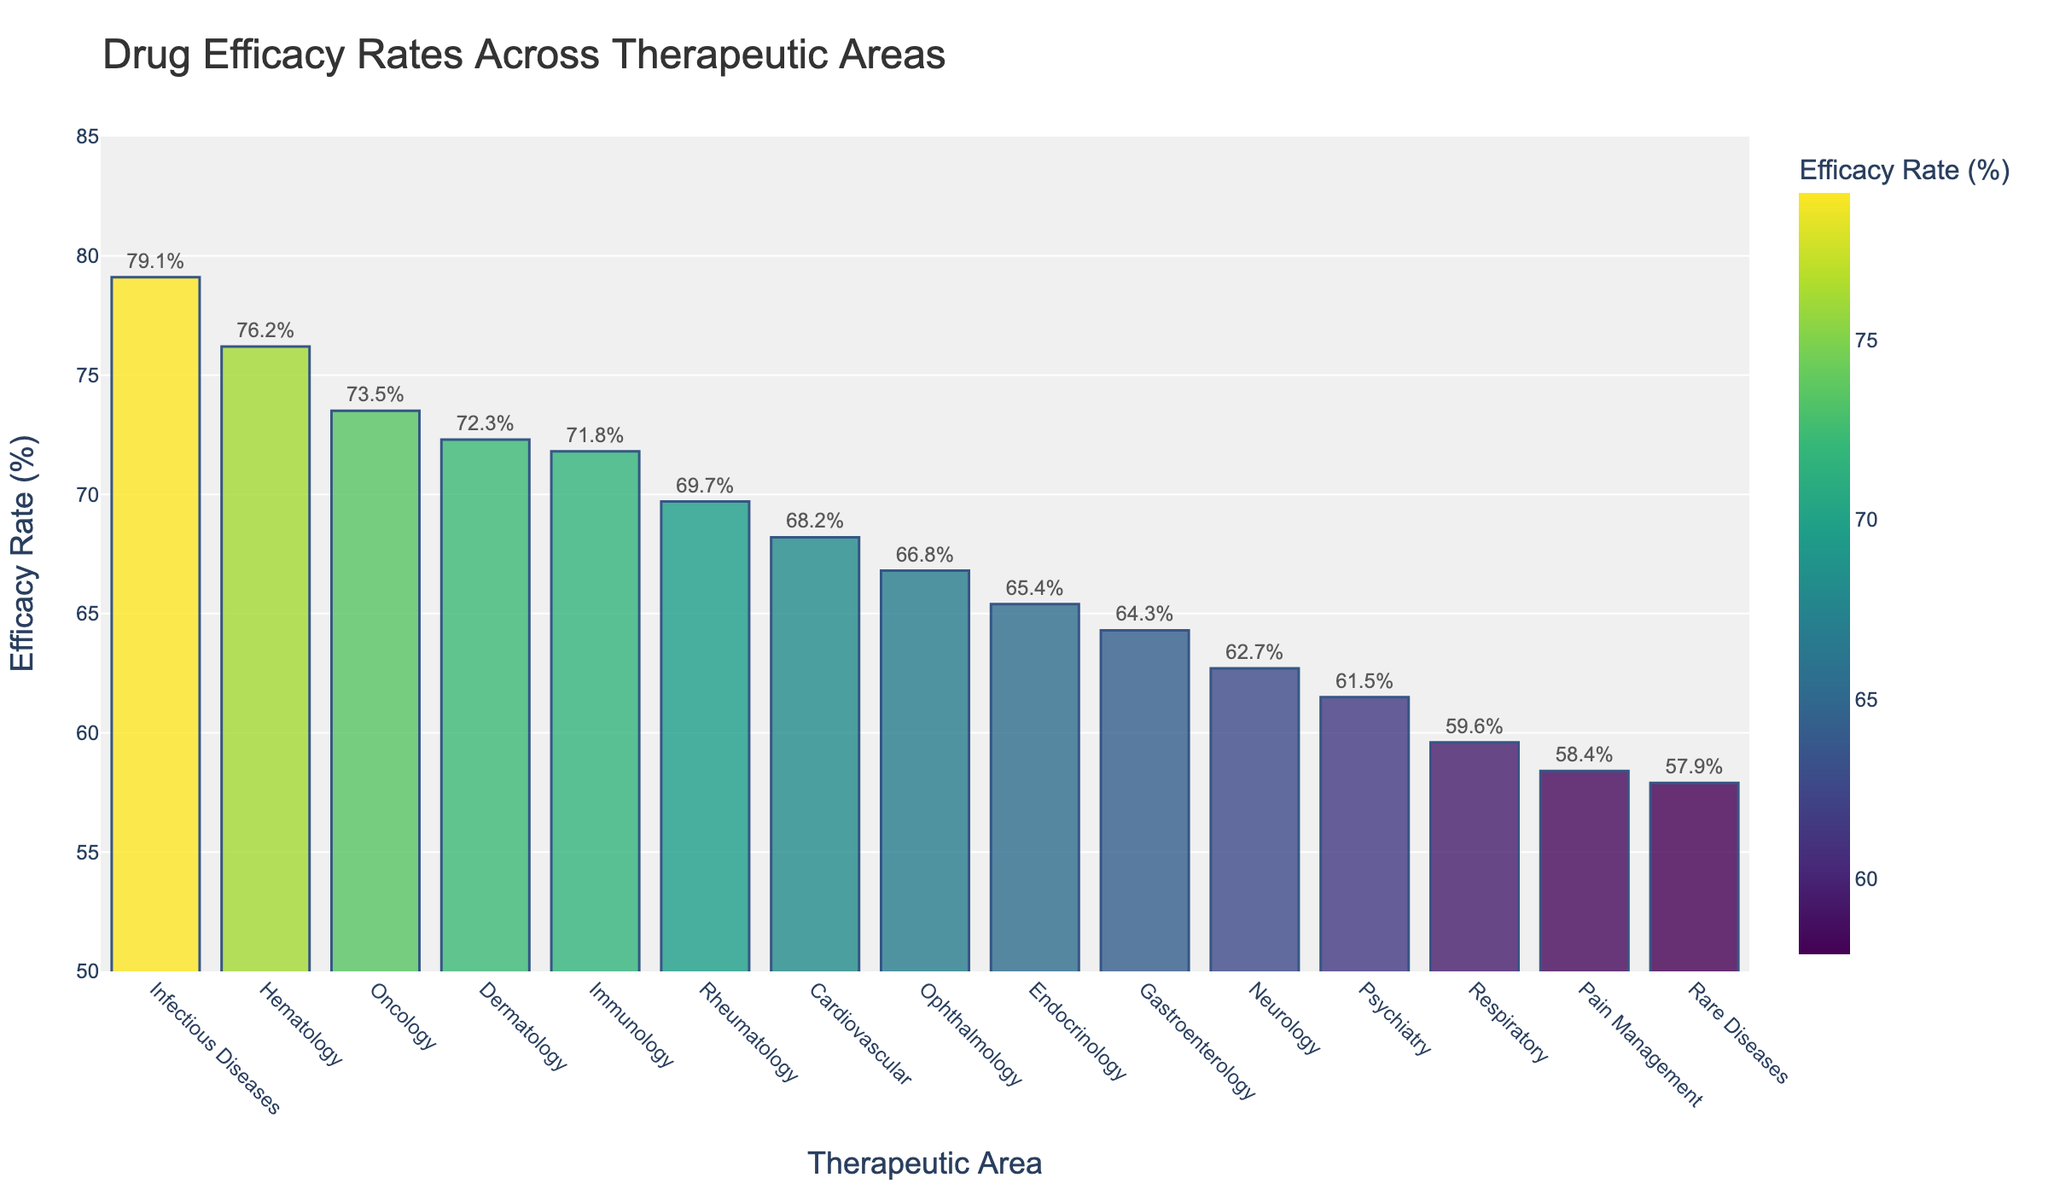Which therapeutic area has the highest drug efficacy rate? By visually inspecting the bar chart, we can identify the tallest bar. The therapeutic area with the highest bar represents the one with the highest drug efficacy rate.
Answer: Infectious Diseases Which therapeutic area has the lowest drug efficacy rate? Observing the bar chart, we look for the shortest bar as it represents the lowest drug efficacy rate among all therapeutic areas.
Answer: Rare Diseases How much higher is the efficacy rate of Oncology compared to Psychiatry? Locate the bars for Oncology and Psychiatry by the therapeutic areas on the x-axis. The height difference between these bars corresponds to their efficacy rate difference. Oncology is 73.5%, and Psychiatry is 61.5%. The calculation is 73.5% - 61.5% = 12%.
Answer: 12% What is the average efficacy rate of Oncology, Hematology, and Dermatology? Find the efficacy rates for the three therapeutic areas: Oncology (73.5%), Hematology (76.2%), and Dermatology (72.3%). Add these rates: 73.5 + 76.2 + 72.3 = 222. Divide the sum by 3 to find the average: 222 / 3 = 74%.
Answer: 74% Are there more therapeutic areas with efficacy rates above or below 65%? By counting the number of bars above and below the 65% mark, we determine how many therapeutic areas fall into each category. There are 8 therapeutic areas above 65% and 7 below.
Answer: Above Which two therapeutic areas have an efficacy rate closest to each other? Identifying bars with heights very close to each other, we find the efficacy rates for these therapeutic areas. Ophthalmology (66.8%) and Endocrinology (65.4%) have a small difference of 66.8% - 65.4% = 1.4%.
Answer: Ophthalmology and Endocrinology How much greater is the efficacy rate of Cardiovascular compared to Pain Management? Locate the bars for Cardiovascular and Pain Management. Cardiovascular is 68.2%, and Pain Management is 58.4%. The difference is calculated as 68.2% - 58.4% = 9.8%.
Answer: 9.8% Which therapeutic area has a higher efficacy rate: Neurology or Rheumatology? By comparing the heights of the bars for Neurology (62.7%) and Rheumatology (69.7%), we can determine which is higher. Rheumatology is higher than Neurology.
Answer: Rheumatology What is the range of drug efficacy rates across all therapeutic areas? Identify the highest and lowest efficacy rates from the chart. The highest is 79.1% (Infectious Diseases) and the lowest is 57.9% (Rare Diseases). The range is 79.1% - 57.9% = 21.2%.
Answer: 21.2% What is the total combined efficacy rate for Endocrinology, Gastroenterology, and Ophthalmology? Retrieve the efficacy rates: Endocrinology (65.4%), Gastroenterology (64.3%), and Ophthalmology (66.8%). Sum these values: 65.4 + 64.3 + 66.8 = 196.5%.
Answer: 196.5% 